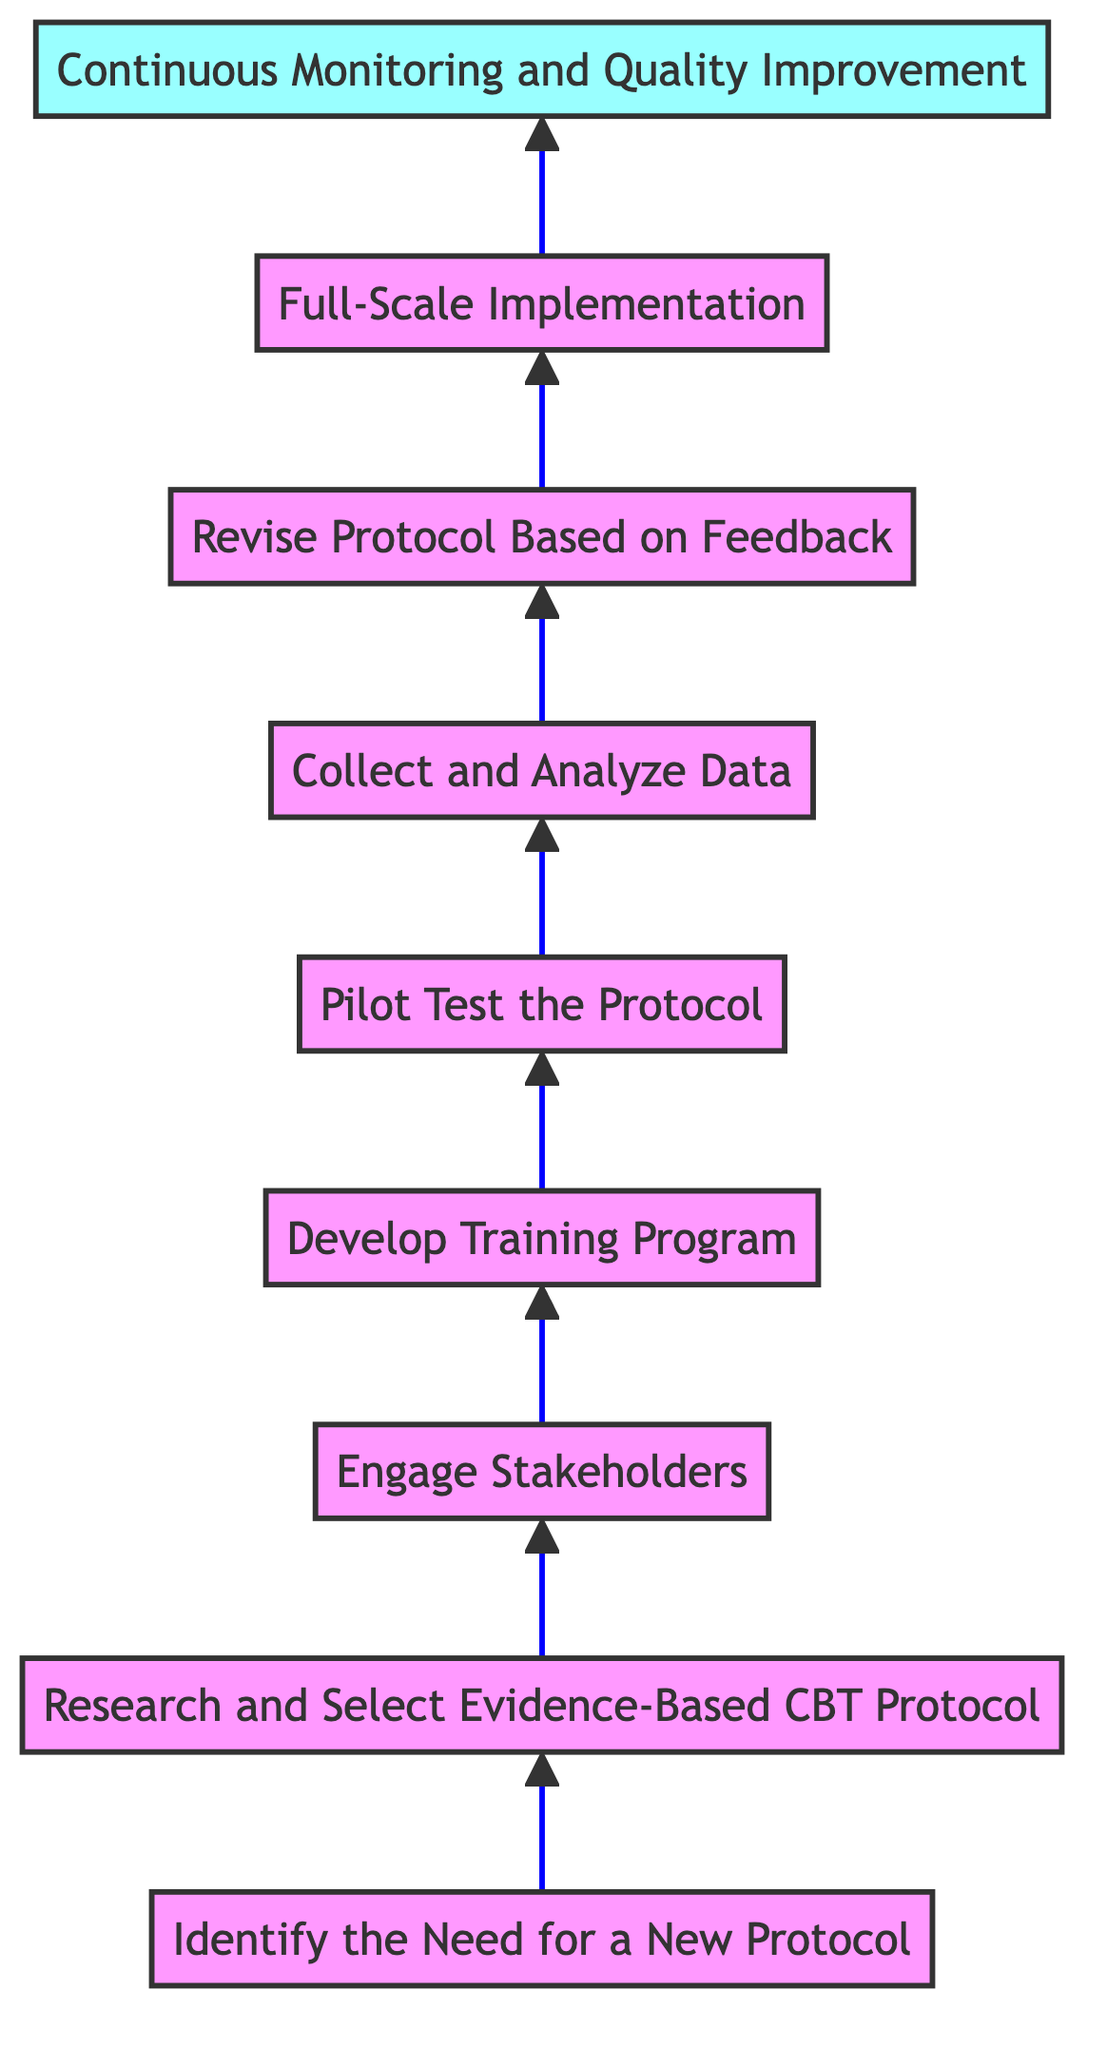What is the first step in the diagram? The first step is labeled "Identify the Need for a New Protocol," which is located at the bottom of the flow chart. It is the starting point of the entire process.
Answer: Identify the Need for a New Protocol How many total steps are in the flow chart? There are a total of nine steps in the flow chart, each representing a different phase in implementing a new CBT protocol.
Answer: Nine Which step comes after "Pilot Test the Protocol"? The step that comes after "Pilot Test the Protocol" is "Collect and Analyze Data," indicating the need to evaluate the pilot implementation.
Answer: Collect and Analyze Data What is the last step in the process? The last step is labeled "Continuous Monitoring and Quality Improvement," which emphasizes the ongoing nature of the protocol's implementation and assessment.
Answer: Continuous Monitoring and Quality Improvement Which two steps are directly related to feedback? The steps directly related to feedback are "Collect and Analyze Data" and "Revise Protocol Based on Feedback," showing the importance of evaluations to improve the protocol.
Answer: Collect and Analyze Data, Revise Protocol Based on Feedback Which step involves engaging clinical staff and patients? The step that involves engaging clinical staff and patients is "Engage Stakeholders," focusing on gaining buy-in and considering input from these groups.
Answer: Engage Stakeholders What is the purpose of the "Develop Training Program" step? The purpose of the "Develop Training Program" step is to create a comprehensive training plan for clinicians to ensure proper implementation of the new CBT protocol.
Answer: Create a comprehensive training plan What is the sequential order from the 2nd step to the 5th step? The sequential order is: "Research and Select Evidence-Based CBT Protocol" (2) → "Engage Stakeholders" (3) → "Develop Training Program" (4) → "Pilot Test the Protocol" (5). Each follows logically from the previous one in the implementation process.
Answer: Research, Engage, Develop, Pilot What type of chart is this? This diagram is a Bottom to Top Flow Chart. It emphasizes a stepwise approach with directionality indicating progression from initial needs to ongoing improvement.
Answer: Bottom to Top Flow Chart 